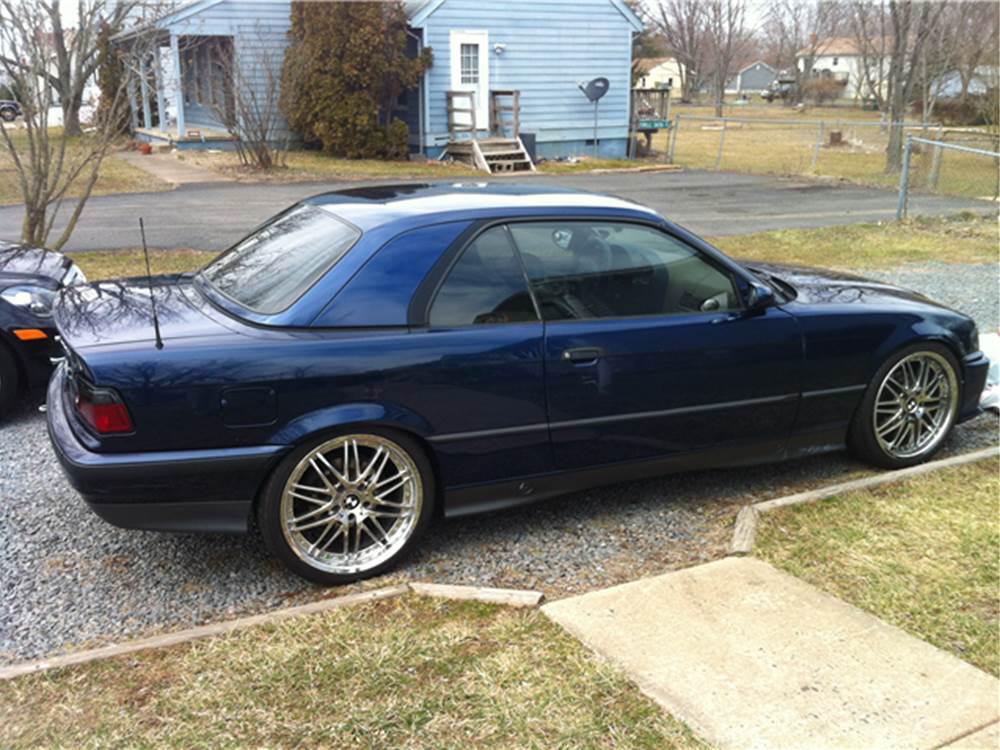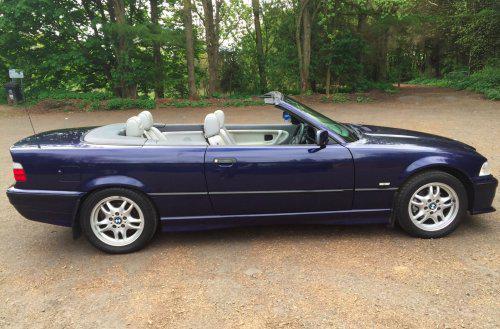The first image is the image on the left, the second image is the image on the right. Examine the images to the left and right. Is the description "There are two cars, but only one roof." accurate? Answer yes or no. Yes. The first image is the image on the left, the second image is the image on the right. Evaluate the accuracy of this statement regarding the images: "The car in the right image is facing towards the right.". Is it true? Answer yes or no. Yes. 